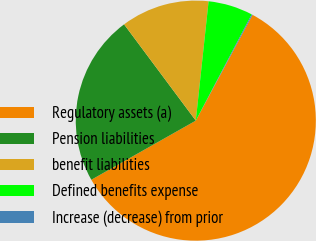Convert chart. <chart><loc_0><loc_0><loc_500><loc_500><pie_chart><fcel>Regulatory assets (a)<fcel>Pension liabilities<fcel>benefit liabilities<fcel>Defined benefits expense<fcel>Increase (decrease) from prior<nl><fcel>58.96%<fcel>23.01%<fcel>11.89%<fcel>6.01%<fcel>0.13%<nl></chart> 